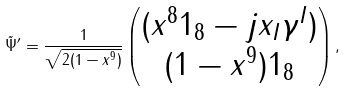<formula> <loc_0><loc_0><loc_500><loc_500>\tilde { \Psi } ^ { \prime } = \frac { 1 } { \sqrt { 2 ( 1 - x ^ { 9 } ) } } \begin{pmatrix} ( x ^ { 8 } 1 _ { 8 } - j x _ { I } \gamma ^ { I } ) \\ ( 1 - x ^ { 9 } ) 1 _ { 8 } \end{pmatrix} ,</formula> 